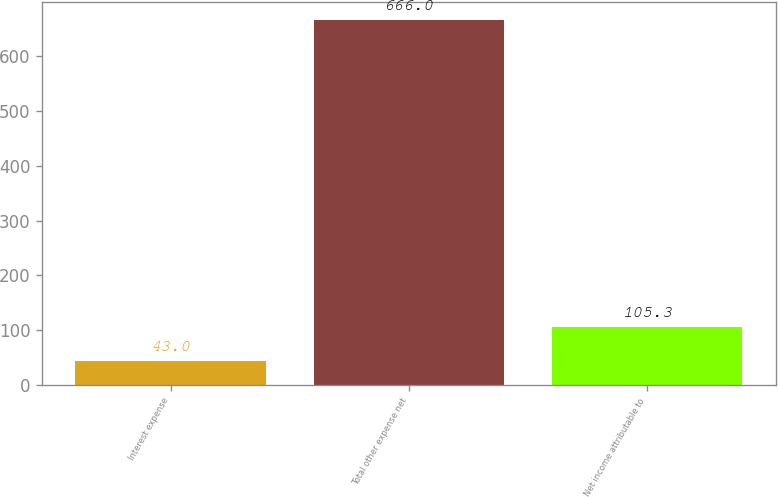Convert chart to OTSL. <chart><loc_0><loc_0><loc_500><loc_500><bar_chart><fcel>Interest expense<fcel>Total other expense net<fcel>Net income attributable to<nl><fcel>43<fcel>666<fcel>105.3<nl></chart> 